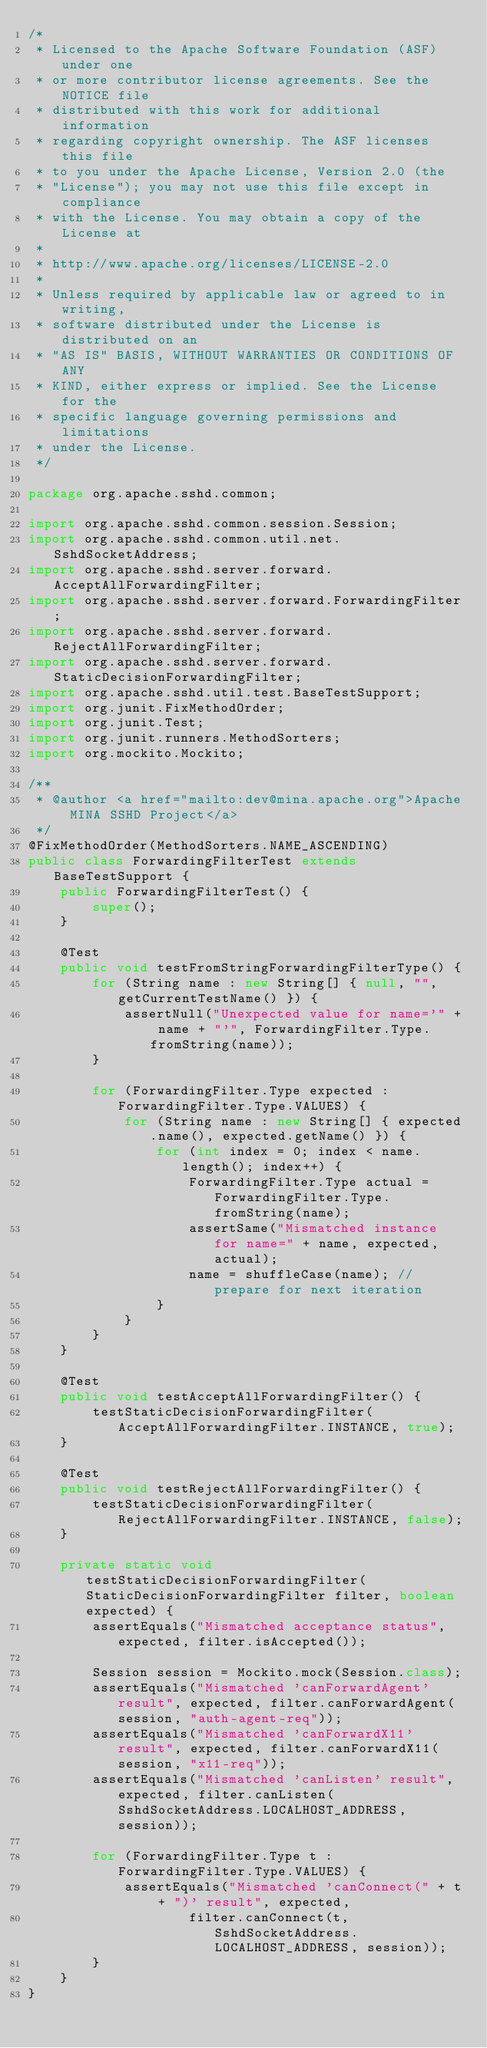<code> <loc_0><loc_0><loc_500><loc_500><_Java_>/*
 * Licensed to the Apache Software Foundation (ASF) under one
 * or more contributor license agreements. See the NOTICE file
 * distributed with this work for additional information
 * regarding copyright ownership. The ASF licenses this file
 * to you under the Apache License, Version 2.0 (the
 * "License"); you may not use this file except in compliance
 * with the License. You may obtain a copy of the License at
 *
 * http://www.apache.org/licenses/LICENSE-2.0
 *
 * Unless required by applicable law or agreed to in writing,
 * software distributed under the License is distributed on an
 * "AS IS" BASIS, WITHOUT WARRANTIES OR CONDITIONS OF ANY
 * KIND, either express or implied. See the License for the
 * specific language governing permissions and limitations
 * under the License.
 */

package org.apache.sshd.common;

import org.apache.sshd.common.session.Session;
import org.apache.sshd.common.util.net.SshdSocketAddress;
import org.apache.sshd.server.forward.AcceptAllForwardingFilter;
import org.apache.sshd.server.forward.ForwardingFilter;
import org.apache.sshd.server.forward.RejectAllForwardingFilter;
import org.apache.sshd.server.forward.StaticDecisionForwardingFilter;
import org.apache.sshd.util.test.BaseTestSupport;
import org.junit.FixMethodOrder;
import org.junit.Test;
import org.junit.runners.MethodSorters;
import org.mockito.Mockito;

/**
 * @author <a href="mailto:dev@mina.apache.org">Apache MINA SSHD Project</a>
 */
@FixMethodOrder(MethodSorters.NAME_ASCENDING)
public class ForwardingFilterTest extends BaseTestSupport {
    public ForwardingFilterTest() {
        super();
    }

    @Test
    public void testFromStringForwardingFilterType() {
        for (String name : new String[] { null, "", getCurrentTestName() }) {
            assertNull("Unexpected value for name='" + name + "'", ForwardingFilter.Type.fromString(name));
        }

        for (ForwardingFilter.Type expected : ForwardingFilter.Type.VALUES) {
            for (String name : new String[] { expected.name(), expected.getName() }) {
                for (int index = 0; index < name.length(); index++) {
                    ForwardingFilter.Type actual = ForwardingFilter.Type.fromString(name);
                    assertSame("Mismatched instance for name=" + name, expected, actual);
                    name = shuffleCase(name); // prepare for next iteration
                }
            }
        }
    }

    @Test
    public void testAcceptAllForwardingFilter() {
        testStaticDecisionForwardingFilter(AcceptAllForwardingFilter.INSTANCE, true);
    }

    @Test
    public void testRejectAllForwardingFilter() {
        testStaticDecisionForwardingFilter(RejectAllForwardingFilter.INSTANCE, false);
    }

    private static void testStaticDecisionForwardingFilter(StaticDecisionForwardingFilter filter, boolean expected) {
        assertEquals("Mismatched acceptance status", expected, filter.isAccepted());

        Session session = Mockito.mock(Session.class);
        assertEquals("Mismatched 'canForwardAgent' result", expected, filter.canForwardAgent(session, "auth-agent-req"));
        assertEquals("Mismatched 'canForwardX11' result", expected, filter.canForwardX11(session, "x11-req"));
        assertEquals("Mismatched 'canListen' result", expected, filter.canListen(SshdSocketAddress.LOCALHOST_ADDRESS, session));

        for (ForwardingFilter.Type t : ForwardingFilter.Type.VALUES) {
            assertEquals("Mismatched 'canConnect(" + t + ")' result", expected,
                    filter.canConnect(t, SshdSocketAddress.LOCALHOST_ADDRESS, session));
        }
    }
}
</code> 